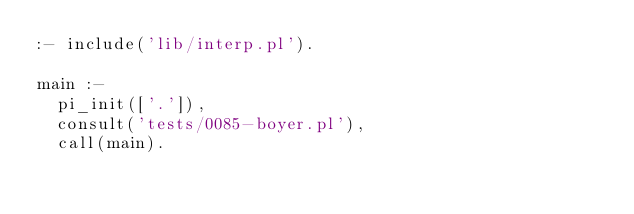<code> <loc_0><loc_0><loc_500><loc_500><_Perl_>:- include('lib/interp.pl').

main :-
	pi_init(['.']),
	consult('tests/0085-boyer.pl'),
	call(main).
</code> 